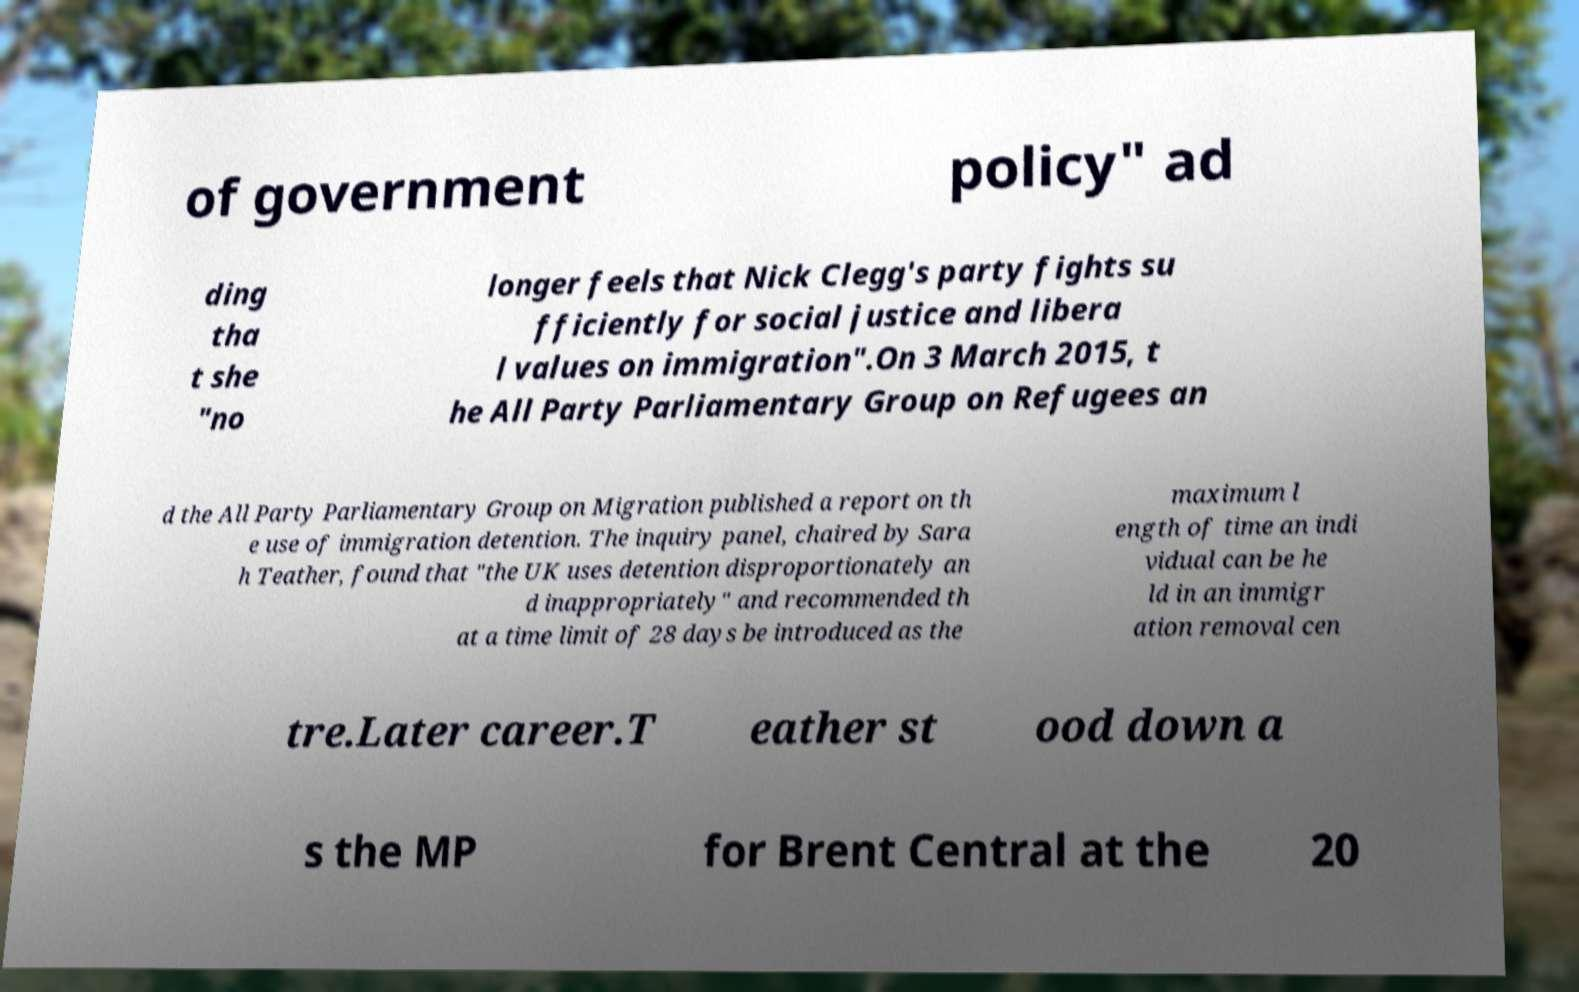Could you assist in decoding the text presented in this image and type it out clearly? of government policy" ad ding tha t she "no longer feels that Nick Clegg's party fights su fficiently for social justice and libera l values on immigration".On 3 March 2015, t he All Party Parliamentary Group on Refugees an d the All Party Parliamentary Group on Migration published a report on th e use of immigration detention. The inquiry panel, chaired by Sara h Teather, found that "the UK uses detention disproportionately an d inappropriately" and recommended th at a time limit of 28 days be introduced as the maximum l ength of time an indi vidual can be he ld in an immigr ation removal cen tre.Later career.T eather st ood down a s the MP for Brent Central at the 20 